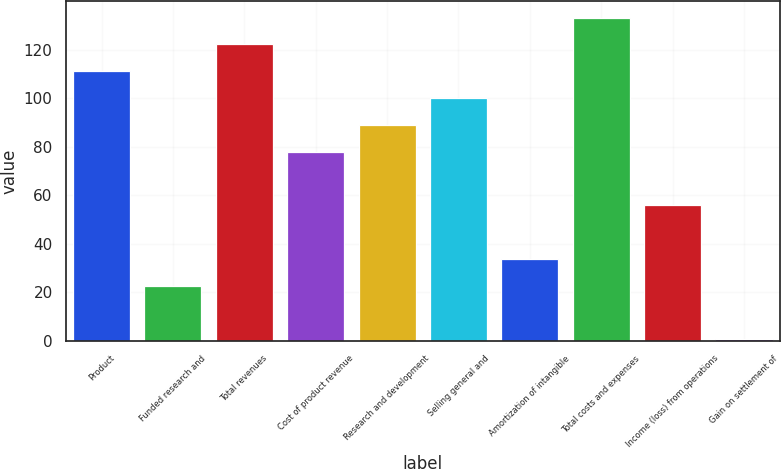Convert chart. <chart><loc_0><loc_0><loc_500><loc_500><bar_chart><fcel>Product<fcel>Funded research and<fcel>Total revenues<fcel>Cost of product revenue<fcel>Research and development<fcel>Selling general and<fcel>Amortization of intangible<fcel>Total costs and expenses<fcel>Income (loss) from operations<fcel>Gain on settlement of<nl><fcel>111.1<fcel>22.62<fcel>122.16<fcel>77.92<fcel>88.98<fcel>100.04<fcel>33.68<fcel>133.22<fcel>55.8<fcel>0.5<nl></chart> 